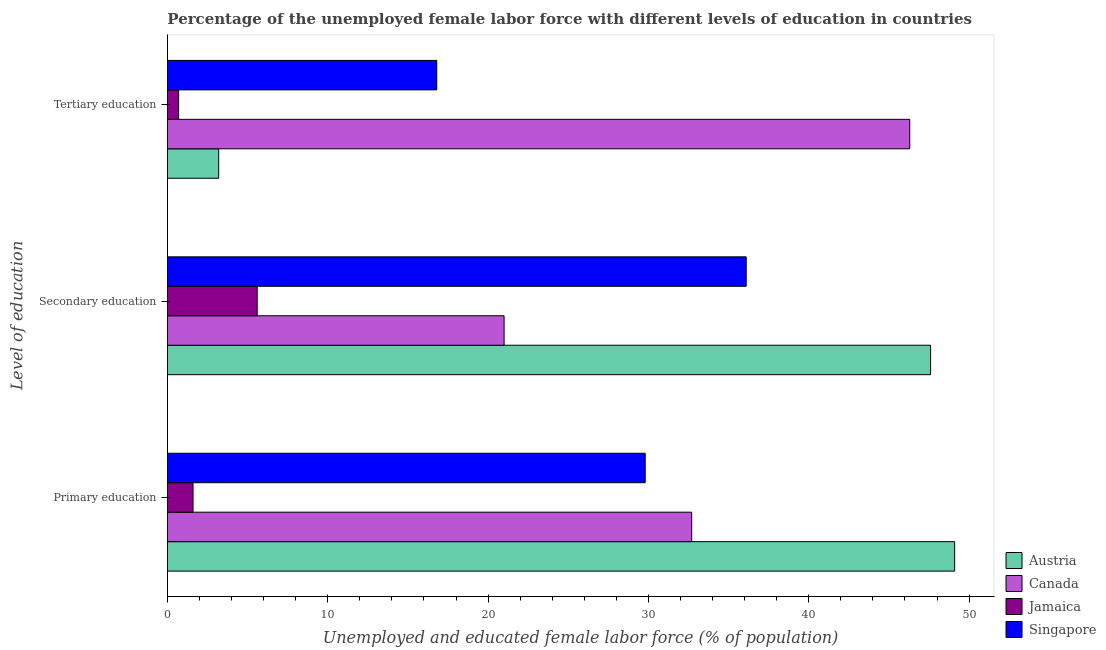Are the number of bars per tick equal to the number of legend labels?
Keep it short and to the point. Yes. Are the number of bars on each tick of the Y-axis equal?
Make the answer very short. Yes. How many bars are there on the 1st tick from the top?
Your answer should be compact. 4. What is the label of the 3rd group of bars from the top?
Your answer should be compact. Primary education. What is the percentage of female labor force who received primary education in Jamaica?
Ensure brevity in your answer.  1.6. Across all countries, what is the maximum percentage of female labor force who received tertiary education?
Ensure brevity in your answer.  46.3. Across all countries, what is the minimum percentage of female labor force who received primary education?
Provide a short and direct response. 1.6. In which country was the percentage of female labor force who received secondary education minimum?
Offer a very short reply. Jamaica. What is the total percentage of female labor force who received secondary education in the graph?
Make the answer very short. 110.3. What is the difference between the percentage of female labor force who received tertiary education in Jamaica and that in Singapore?
Provide a short and direct response. -16.1. What is the difference between the percentage of female labor force who received secondary education in Canada and the percentage of female labor force who received primary education in Jamaica?
Your answer should be compact. 19.4. What is the average percentage of female labor force who received secondary education per country?
Give a very brief answer. 27.57. What is the difference between the percentage of female labor force who received tertiary education and percentage of female labor force who received primary education in Jamaica?
Provide a short and direct response. -0.9. In how many countries, is the percentage of female labor force who received secondary education greater than 18 %?
Keep it short and to the point. 3. What is the ratio of the percentage of female labor force who received primary education in Singapore to that in Jamaica?
Keep it short and to the point. 18.62. Is the percentage of female labor force who received tertiary education in Jamaica less than that in Austria?
Give a very brief answer. Yes. Is the difference between the percentage of female labor force who received primary education in Canada and Austria greater than the difference between the percentage of female labor force who received secondary education in Canada and Austria?
Make the answer very short. Yes. What is the difference between the highest and the second highest percentage of female labor force who received primary education?
Provide a short and direct response. 16.4. What is the difference between the highest and the lowest percentage of female labor force who received tertiary education?
Offer a terse response. 45.6. What does the 3rd bar from the bottom in Primary education represents?
Your response must be concise. Jamaica. Are all the bars in the graph horizontal?
Keep it short and to the point. Yes. What is the difference between two consecutive major ticks on the X-axis?
Offer a very short reply. 10. Are the values on the major ticks of X-axis written in scientific E-notation?
Ensure brevity in your answer.  No. Does the graph contain any zero values?
Make the answer very short. No. Where does the legend appear in the graph?
Your response must be concise. Bottom right. How many legend labels are there?
Give a very brief answer. 4. How are the legend labels stacked?
Offer a very short reply. Vertical. What is the title of the graph?
Provide a succinct answer. Percentage of the unemployed female labor force with different levels of education in countries. Does "United Kingdom" appear as one of the legend labels in the graph?
Provide a succinct answer. No. What is the label or title of the X-axis?
Keep it short and to the point. Unemployed and educated female labor force (% of population). What is the label or title of the Y-axis?
Keep it short and to the point. Level of education. What is the Unemployed and educated female labor force (% of population) of Austria in Primary education?
Make the answer very short. 49.1. What is the Unemployed and educated female labor force (% of population) of Canada in Primary education?
Your answer should be compact. 32.7. What is the Unemployed and educated female labor force (% of population) in Jamaica in Primary education?
Provide a short and direct response. 1.6. What is the Unemployed and educated female labor force (% of population) in Singapore in Primary education?
Provide a short and direct response. 29.8. What is the Unemployed and educated female labor force (% of population) in Austria in Secondary education?
Provide a short and direct response. 47.6. What is the Unemployed and educated female labor force (% of population) of Canada in Secondary education?
Ensure brevity in your answer.  21. What is the Unemployed and educated female labor force (% of population) of Jamaica in Secondary education?
Your answer should be very brief. 5.6. What is the Unemployed and educated female labor force (% of population) of Singapore in Secondary education?
Ensure brevity in your answer.  36.1. What is the Unemployed and educated female labor force (% of population) in Austria in Tertiary education?
Your answer should be very brief. 3.2. What is the Unemployed and educated female labor force (% of population) in Canada in Tertiary education?
Your answer should be compact. 46.3. What is the Unemployed and educated female labor force (% of population) in Jamaica in Tertiary education?
Provide a short and direct response. 0.7. What is the Unemployed and educated female labor force (% of population) in Singapore in Tertiary education?
Your response must be concise. 16.8. Across all Level of education, what is the maximum Unemployed and educated female labor force (% of population) in Austria?
Provide a short and direct response. 49.1. Across all Level of education, what is the maximum Unemployed and educated female labor force (% of population) in Canada?
Offer a terse response. 46.3. Across all Level of education, what is the maximum Unemployed and educated female labor force (% of population) of Jamaica?
Offer a very short reply. 5.6. Across all Level of education, what is the maximum Unemployed and educated female labor force (% of population) in Singapore?
Ensure brevity in your answer.  36.1. Across all Level of education, what is the minimum Unemployed and educated female labor force (% of population) of Austria?
Your answer should be very brief. 3.2. Across all Level of education, what is the minimum Unemployed and educated female labor force (% of population) in Canada?
Keep it short and to the point. 21. Across all Level of education, what is the minimum Unemployed and educated female labor force (% of population) in Jamaica?
Make the answer very short. 0.7. Across all Level of education, what is the minimum Unemployed and educated female labor force (% of population) of Singapore?
Provide a short and direct response. 16.8. What is the total Unemployed and educated female labor force (% of population) in Austria in the graph?
Ensure brevity in your answer.  99.9. What is the total Unemployed and educated female labor force (% of population) of Singapore in the graph?
Offer a very short reply. 82.7. What is the difference between the Unemployed and educated female labor force (% of population) of Austria in Primary education and that in Secondary education?
Offer a very short reply. 1.5. What is the difference between the Unemployed and educated female labor force (% of population) in Canada in Primary education and that in Secondary education?
Make the answer very short. 11.7. What is the difference between the Unemployed and educated female labor force (% of population) in Singapore in Primary education and that in Secondary education?
Offer a very short reply. -6.3. What is the difference between the Unemployed and educated female labor force (% of population) of Austria in Primary education and that in Tertiary education?
Your answer should be very brief. 45.9. What is the difference between the Unemployed and educated female labor force (% of population) of Jamaica in Primary education and that in Tertiary education?
Your answer should be compact. 0.9. What is the difference between the Unemployed and educated female labor force (% of population) of Austria in Secondary education and that in Tertiary education?
Provide a short and direct response. 44.4. What is the difference between the Unemployed and educated female labor force (% of population) in Canada in Secondary education and that in Tertiary education?
Ensure brevity in your answer.  -25.3. What is the difference between the Unemployed and educated female labor force (% of population) of Singapore in Secondary education and that in Tertiary education?
Offer a terse response. 19.3. What is the difference between the Unemployed and educated female labor force (% of population) of Austria in Primary education and the Unemployed and educated female labor force (% of population) of Canada in Secondary education?
Offer a terse response. 28.1. What is the difference between the Unemployed and educated female labor force (% of population) of Austria in Primary education and the Unemployed and educated female labor force (% of population) of Jamaica in Secondary education?
Ensure brevity in your answer.  43.5. What is the difference between the Unemployed and educated female labor force (% of population) in Austria in Primary education and the Unemployed and educated female labor force (% of population) in Singapore in Secondary education?
Ensure brevity in your answer.  13. What is the difference between the Unemployed and educated female labor force (% of population) in Canada in Primary education and the Unemployed and educated female labor force (% of population) in Jamaica in Secondary education?
Offer a terse response. 27.1. What is the difference between the Unemployed and educated female labor force (% of population) in Jamaica in Primary education and the Unemployed and educated female labor force (% of population) in Singapore in Secondary education?
Your response must be concise. -34.5. What is the difference between the Unemployed and educated female labor force (% of population) in Austria in Primary education and the Unemployed and educated female labor force (% of population) in Jamaica in Tertiary education?
Your answer should be very brief. 48.4. What is the difference between the Unemployed and educated female labor force (% of population) in Austria in Primary education and the Unemployed and educated female labor force (% of population) in Singapore in Tertiary education?
Keep it short and to the point. 32.3. What is the difference between the Unemployed and educated female labor force (% of population) in Canada in Primary education and the Unemployed and educated female labor force (% of population) in Singapore in Tertiary education?
Make the answer very short. 15.9. What is the difference between the Unemployed and educated female labor force (% of population) of Jamaica in Primary education and the Unemployed and educated female labor force (% of population) of Singapore in Tertiary education?
Make the answer very short. -15.2. What is the difference between the Unemployed and educated female labor force (% of population) of Austria in Secondary education and the Unemployed and educated female labor force (% of population) of Jamaica in Tertiary education?
Your answer should be compact. 46.9. What is the difference between the Unemployed and educated female labor force (% of population) in Austria in Secondary education and the Unemployed and educated female labor force (% of population) in Singapore in Tertiary education?
Make the answer very short. 30.8. What is the difference between the Unemployed and educated female labor force (% of population) in Canada in Secondary education and the Unemployed and educated female labor force (% of population) in Jamaica in Tertiary education?
Provide a succinct answer. 20.3. What is the difference between the Unemployed and educated female labor force (% of population) in Canada in Secondary education and the Unemployed and educated female labor force (% of population) in Singapore in Tertiary education?
Your answer should be compact. 4.2. What is the difference between the Unemployed and educated female labor force (% of population) of Jamaica in Secondary education and the Unemployed and educated female labor force (% of population) of Singapore in Tertiary education?
Your answer should be very brief. -11.2. What is the average Unemployed and educated female labor force (% of population) of Austria per Level of education?
Provide a succinct answer. 33.3. What is the average Unemployed and educated female labor force (% of population) of Canada per Level of education?
Provide a short and direct response. 33.33. What is the average Unemployed and educated female labor force (% of population) in Jamaica per Level of education?
Keep it short and to the point. 2.63. What is the average Unemployed and educated female labor force (% of population) in Singapore per Level of education?
Provide a short and direct response. 27.57. What is the difference between the Unemployed and educated female labor force (% of population) in Austria and Unemployed and educated female labor force (% of population) in Canada in Primary education?
Offer a terse response. 16.4. What is the difference between the Unemployed and educated female labor force (% of population) in Austria and Unemployed and educated female labor force (% of population) in Jamaica in Primary education?
Provide a succinct answer. 47.5. What is the difference between the Unemployed and educated female labor force (% of population) of Austria and Unemployed and educated female labor force (% of population) of Singapore in Primary education?
Your response must be concise. 19.3. What is the difference between the Unemployed and educated female labor force (% of population) of Canada and Unemployed and educated female labor force (% of population) of Jamaica in Primary education?
Your answer should be very brief. 31.1. What is the difference between the Unemployed and educated female labor force (% of population) of Canada and Unemployed and educated female labor force (% of population) of Singapore in Primary education?
Offer a terse response. 2.9. What is the difference between the Unemployed and educated female labor force (% of population) of Jamaica and Unemployed and educated female labor force (% of population) of Singapore in Primary education?
Your answer should be compact. -28.2. What is the difference between the Unemployed and educated female labor force (% of population) in Austria and Unemployed and educated female labor force (% of population) in Canada in Secondary education?
Ensure brevity in your answer.  26.6. What is the difference between the Unemployed and educated female labor force (% of population) in Canada and Unemployed and educated female labor force (% of population) in Singapore in Secondary education?
Provide a short and direct response. -15.1. What is the difference between the Unemployed and educated female labor force (% of population) in Jamaica and Unemployed and educated female labor force (% of population) in Singapore in Secondary education?
Make the answer very short. -30.5. What is the difference between the Unemployed and educated female labor force (% of population) in Austria and Unemployed and educated female labor force (% of population) in Canada in Tertiary education?
Your answer should be very brief. -43.1. What is the difference between the Unemployed and educated female labor force (% of population) of Austria and Unemployed and educated female labor force (% of population) of Jamaica in Tertiary education?
Your answer should be compact. 2.5. What is the difference between the Unemployed and educated female labor force (% of population) of Austria and Unemployed and educated female labor force (% of population) of Singapore in Tertiary education?
Your answer should be very brief. -13.6. What is the difference between the Unemployed and educated female labor force (% of population) of Canada and Unemployed and educated female labor force (% of population) of Jamaica in Tertiary education?
Keep it short and to the point. 45.6. What is the difference between the Unemployed and educated female labor force (% of population) of Canada and Unemployed and educated female labor force (% of population) of Singapore in Tertiary education?
Offer a terse response. 29.5. What is the difference between the Unemployed and educated female labor force (% of population) in Jamaica and Unemployed and educated female labor force (% of population) in Singapore in Tertiary education?
Give a very brief answer. -16.1. What is the ratio of the Unemployed and educated female labor force (% of population) in Austria in Primary education to that in Secondary education?
Your answer should be compact. 1.03. What is the ratio of the Unemployed and educated female labor force (% of population) in Canada in Primary education to that in Secondary education?
Provide a short and direct response. 1.56. What is the ratio of the Unemployed and educated female labor force (% of population) of Jamaica in Primary education to that in Secondary education?
Give a very brief answer. 0.29. What is the ratio of the Unemployed and educated female labor force (% of population) in Singapore in Primary education to that in Secondary education?
Your answer should be very brief. 0.83. What is the ratio of the Unemployed and educated female labor force (% of population) in Austria in Primary education to that in Tertiary education?
Give a very brief answer. 15.34. What is the ratio of the Unemployed and educated female labor force (% of population) in Canada in Primary education to that in Tertiary education?
Your answer should be very brief. 0.71. What is the ratio of the Unemployed and educated female labor force (% of population) of Jamaica in Primary education to that in Tertiary education?
Provide a succinct answer. 2.29. What is the ratio of the Unemployed and educated female labor force (% of population) in Singapore in Primary education to that in Tertiary education?
Offer a terse response. 1.77. What is the ratio of the Unemployed and educated female labor force (% of population) in Austria in Secondary education to that in Tertiary education?
Give a very brief answer. 14.88. What is the ratio of the Unemployed and educated female labor force (% of population) of Canada in Secondary education to that in Tertiary education?
Make the answer very short. 0.45. What is the ratio of the Unemployed and educated female labor force (% of population) of Singapore in Secondary education to that in Tertiary education?
Make the answer very short. 2.15. What is the difference between the highest and the second highest Unemployed and educated female labor force (% of population) in Austria?
Your answer should be very brief. 1.5. What is the difference between the highest and the second highest Unemployed and educated female labor force (% of population) in Canada?
Offer a terse response. 13.6. What is the difference between the highest and the second highest Unemployed and educated female labor force (% of population) in Singapore?
Provide a short and direct response. 6.3. What is the difference between the highest and the lowest Unemployed and educated female labor force (% of population) of Austria?
Make the answer very short. 45.9. What is the difference between the highest and the lowest Unemployed and educated female labor force (% of population) in Canada?
Offer a terse response. 25.3. What is the difference between the highest and the lowest Unemployed and educated female labor force (% of population) of Jamaica?
Provide a succinct answer. 4.9. What is the difference between the highest and the lowest Unemployed and educated female labor force (% of population) of Singapore?
Make the answer very short. 19.3. 